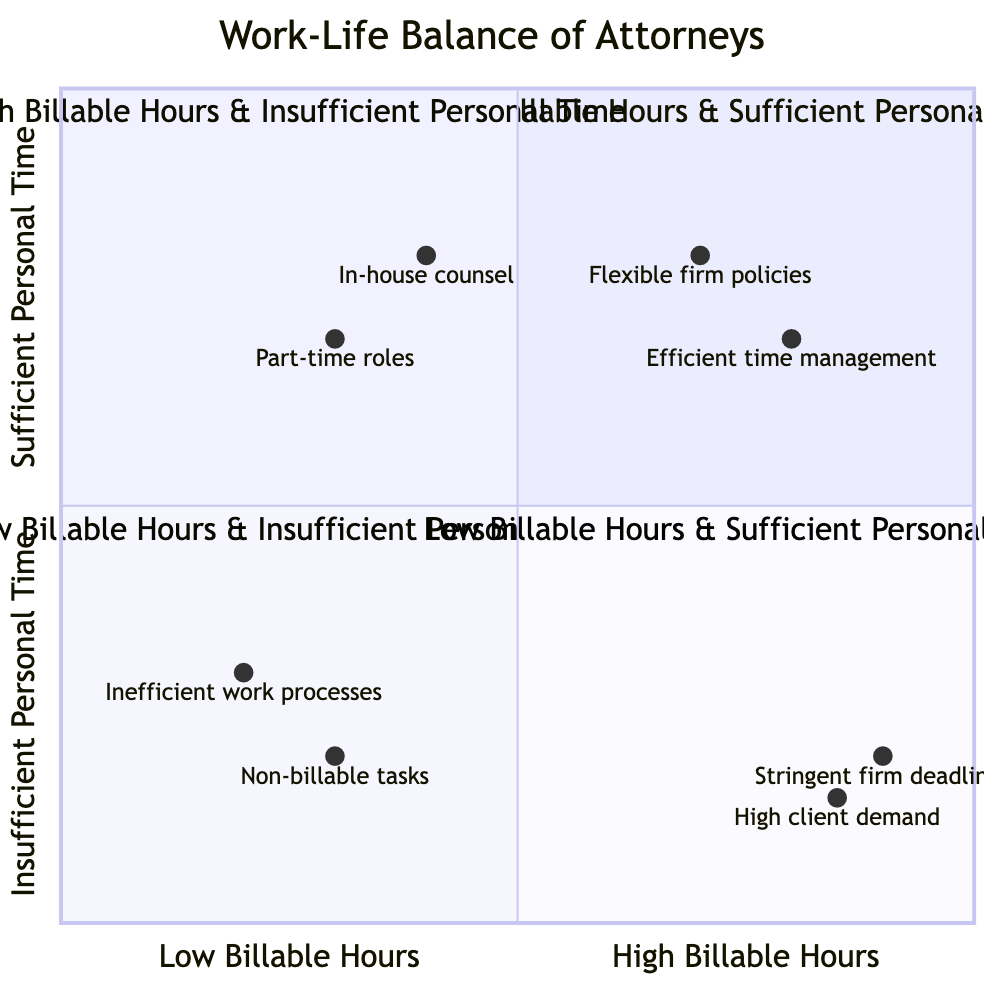What is the title of the quadrant in the top right? The quadrant in the top right is labeled "High Billable Hours & Sufficient Personal Time." This information can be identified directly from the diagram's content, specifying that this is the title attributed to that quadrant.
Answer: High Billable Hours & Sufficient Personal Time How many factors are mentioned in the quadrant chart? By reviewing the content in the diagram, we can identify that there are four quadrants. Each quadrant offers examples or descriptions, but we focus on the number of distinct factors presented. The factors list separate Billable Hours and Personal Time as key components; thus, we count them, resulting in two factors.
Answer: 2 Which quadrant includes "Stringent firm deadlines"? The phrase "Stringent firm deadlines" appears under the examples section for the quadrant termed "High Billable Hours & Insufficient Personal Time." By locating this phrase in the diagram, we correlate it with its related quadrant.
Answer: High Billable Hours & Insufficient Personal Time What type of work environment is illustrated in the bottom left quadrant? The bottom left quadrant labeled "Low Billable Hours & Insufficient Personal Time" depicts attorneys who are struggling with low productivity which is illustrated alongside insufficient personal time. Both the title and description lead us to understand the work environment being characterized as challenging.
Answer: Challenging What number of examples correlate with the "Low Billable Hours & Sufficient Personal Time" quadrant? The "Low Billable Hours & Sufficient Personal Time" quadrant contains three examples provided in the respective section of the diagram, emphasizing roles that allow more personal time with lower work demands. The count of these examples yields our answer.
Answer: 3 Which example is associated with "High client demand"? Upon examination, "High client demand" is listed under the "High Billable Hours & Insufficient Personal Time" quadrant as a primary cause of attorney overwork, linking it to the quadrant's themes. By tracking the example back to its quadrant, we draw our conclusion.
Answer: High Billable Hours & Insufficient Personal Time What characterizes the work situations of attorneys in the bottom right quadrant? Attorneys in the bottom right quadrant labeled "Low Billable Hours & Sufficient Personal Time" are characterized as having lower work demands, indicating a positive work-life balance, though potentially impacting their career progression. This synthesis of the quadrant's content leads to a coherent characterization.
Answer: Positive work-life balance What is the relationship between "Inefficient work processes" and personal time? The example "Inefficient work processes" located in the "Low Billable Hours & Insufficient Personal Time" quadrant suggests a direct impact on personal time, reflecting how inefficiencies consume the time that could otherwise be used for personal activities. This relationship elucidates how work methods might detract from personal time.
Answer: Direct impact on personal time 